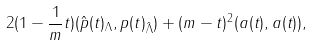<formula> <loc_0><loc_0><loc_500><loc_500>2 ( 1 - \frac { 1 } { m } t ) ( \hat { p } ( t ) _ { \Lambda } , p ( t ) _ { \hat { \Lambda } } ) + ( m - t ) ^ { 2 } ( a ( t ) , a ( t ) ) ,</formula> 